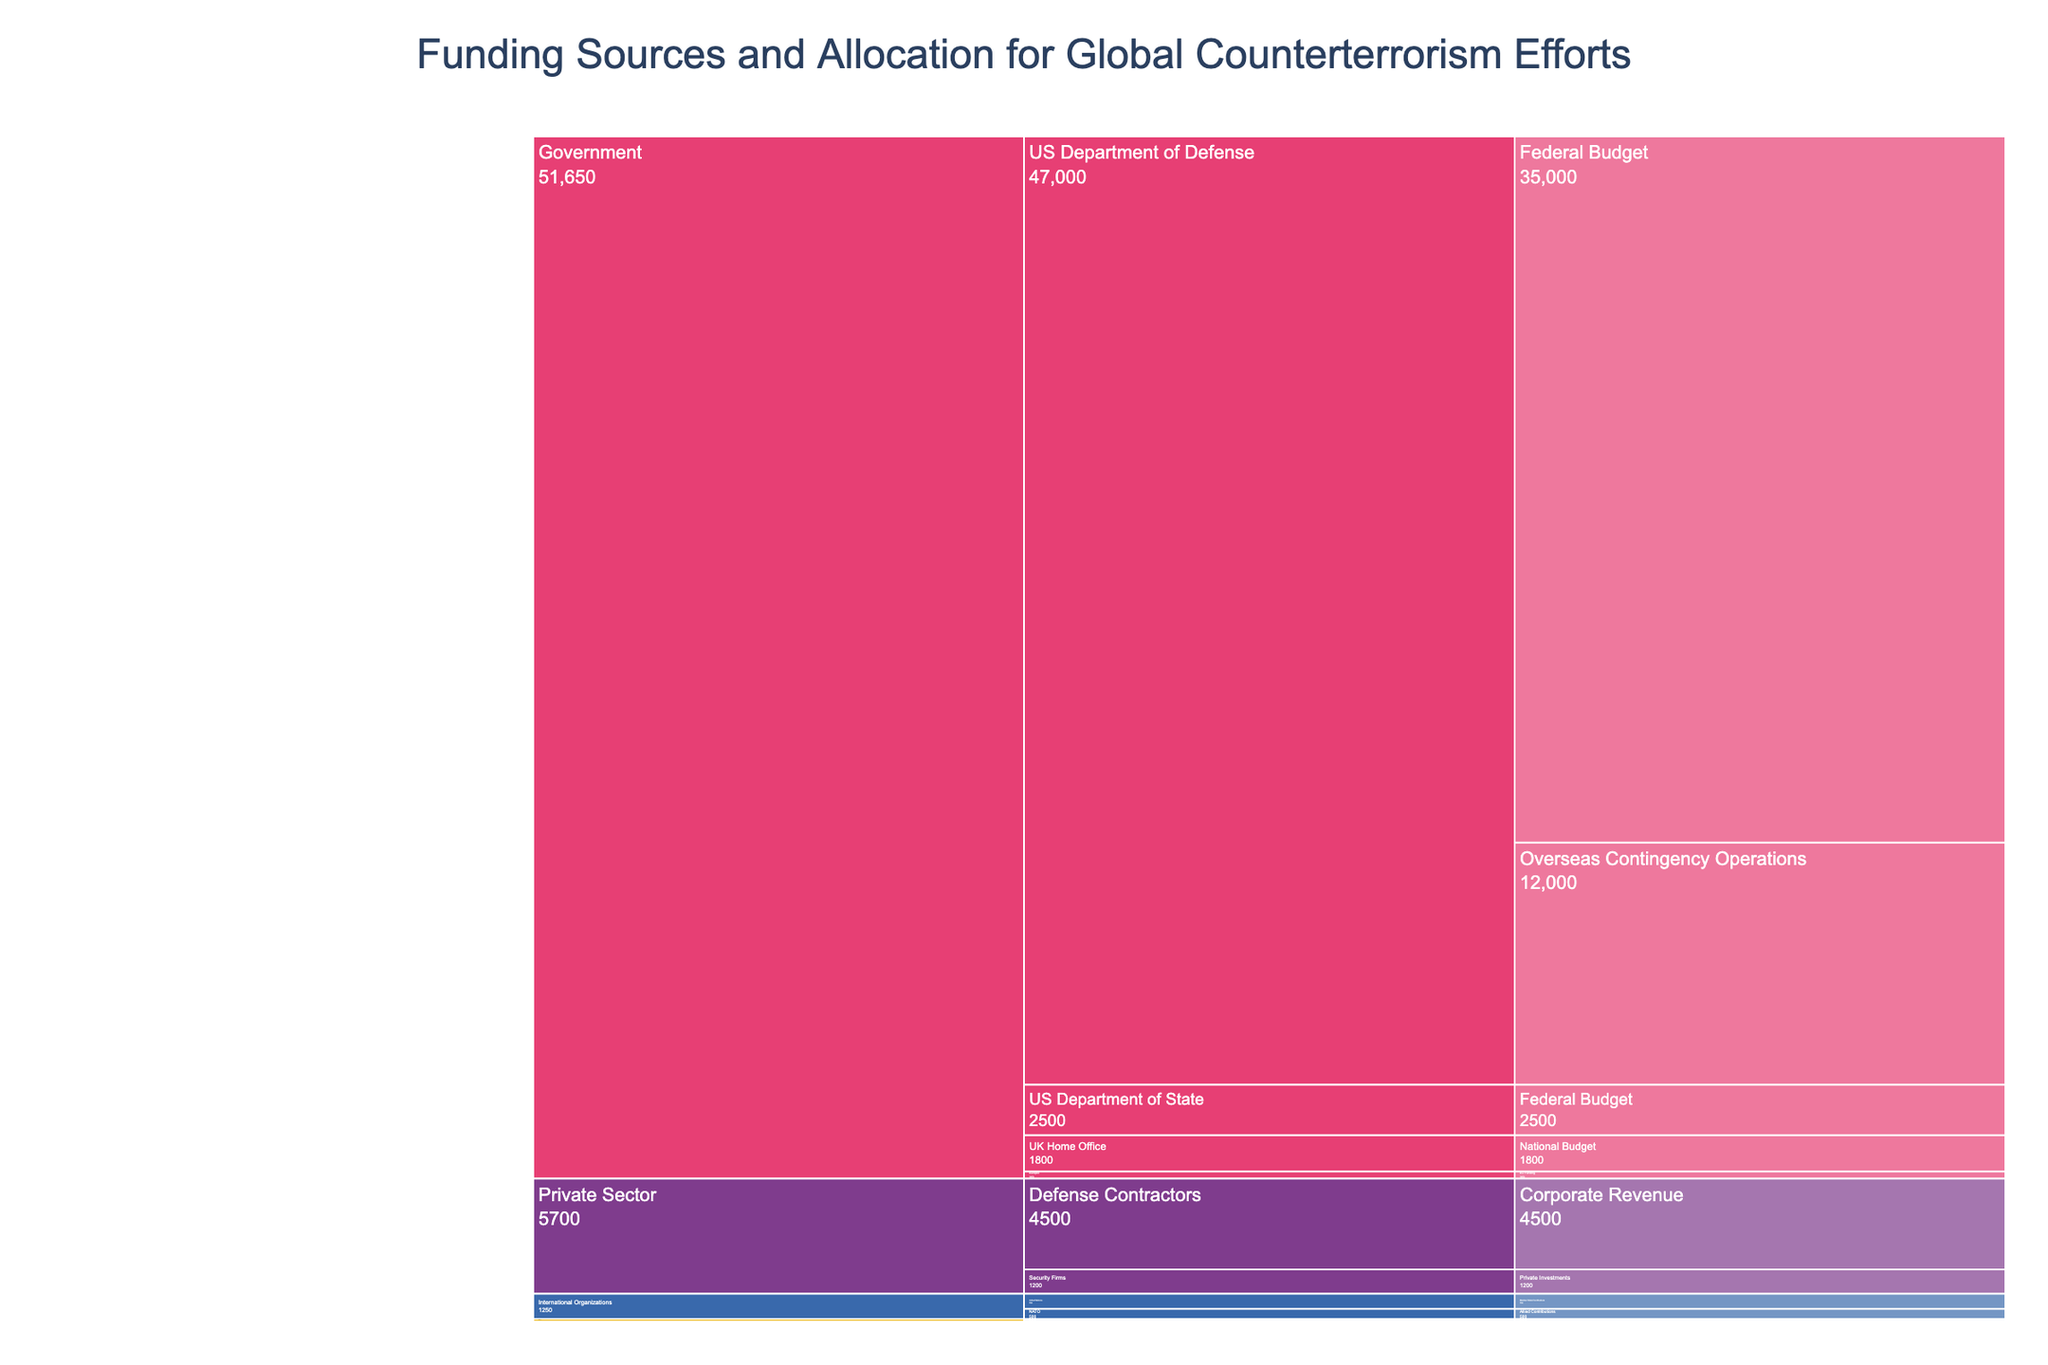What is the title of the Icicle Chart? The title is typically displayed at the top of the chart.
Answer: Funding Sources and Allocation for Global Counterterrorism Efforts How much funding does the US Department of Defense get in total? Sum the amounts from "Federal Budget" and "Overseas Contingency Operations" categories under the US Department of Defense. 35000 + 12000
Answer: 47000 Which category receives the least amount of funding? Compare the total funding amounts for all categories.
Answer: Academic Institutions How does the allocation for the UK's Home Office compare to Europol? Find and compare the funding amounts for the UK's Home Office and Europol. 1800 (UK Home Office) vs. 350 (Europol)
Answer: UK's Home Office receives more funds What are the primary sources of funding for International Organizations? Identify the subcategories and respective funding sources under the "International Organizations" category. Member State Contributions (UN) and Allied Contributions (NATO)
Answer: Member State Contributions and Allied Contributions What is the total amount of funding received by NGOs? Sum the amounts from "Counter Extremism Project" and "Global Center on Cooperative Security." 80 + 45
Answer: 125 Which category receives the highest private sector funding? Determine the category under the "Private Sector" with the highest funding amount. 4500 (Defense Contractors)
Answer: Defense Contractors Compare the funding between Government and Private Sector categories. Sum up the funding amounts under the "Government" and "Private Sector" categories and compare them. Government: 49350 (35000+12000+ 2500 +1800+350) vs. Private Sector: 5700 (4500 + 1200)
Answer: Government receives more funding What is the difference in funding between the US Department of State and the UK's Home Office? Subtract the funding amount for the US Department of State from that of the UK's Home Office. 2500 (US Department of State) - 1800 (UK Home Office)
Answer: 700 Which academic institution receives more funding, and by how much? Compare the funding amounts for Georgetown University and King's College London, and calculate the difference. 25 (Georgetown University) vs. 20 (King's College London); Difference: 25 - 20
Answer: Georgetown University by 5 million USD 